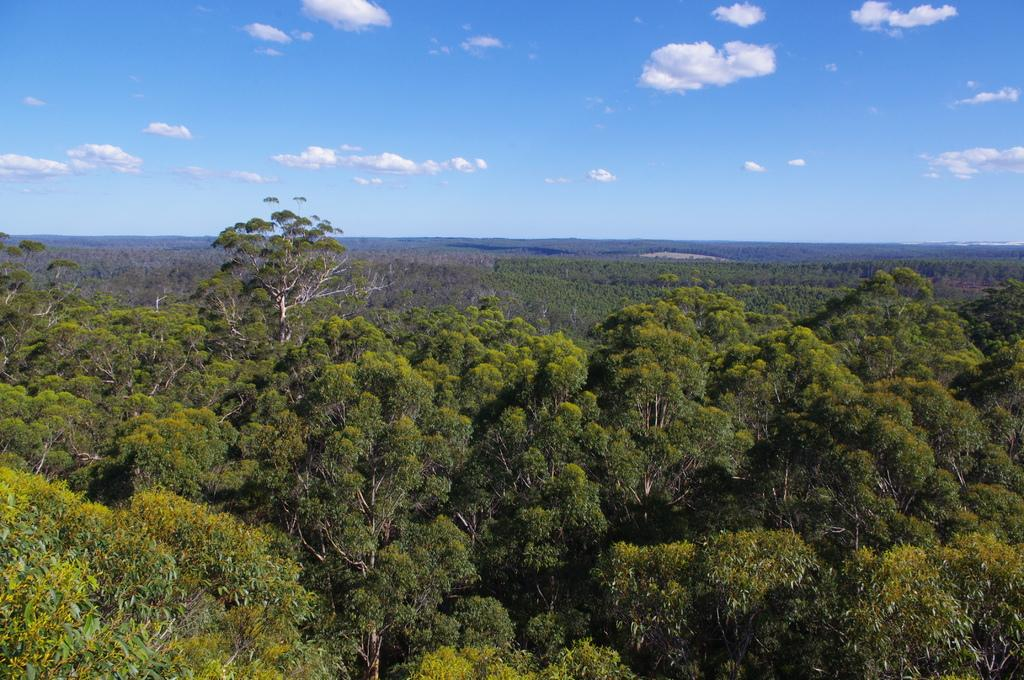What type of vegetation can be seen in the image? There are trees in the image. What is visible in the background of the image? The sky is visible in the background of the image. What can be observed in the sky? Clouds are present in the sky. What type of mark can be seen on the face of the tree in the image? There is no face or mark on the trees in the image; they are simply depicted as trees. 